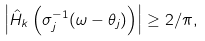<formula> <loc_0><loc_0><loc_500><loc_500>\left | \hat { H } _ { k } \left ( \sigma _ { j } ^ { - 1 } ( \omega - \theta _ { j } ) \right ) \right | \geq 2 / \pi ,</formula> 